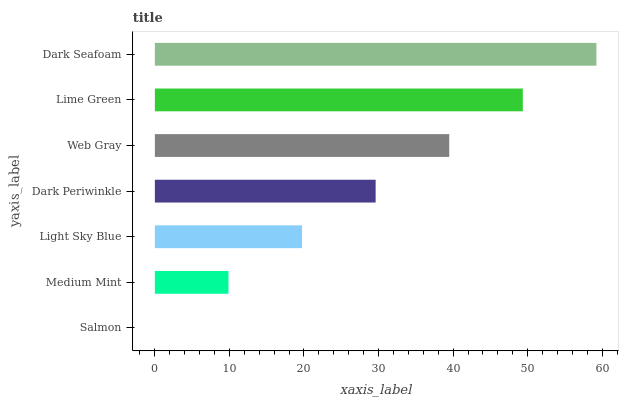Is Salmon the minimum?
Answer yes or no. Yes. Is Dark Seafoam the maximum?
Answer yes or no. Yes. Is Medium Mint the minimum?
Answer yes or no. No. Is Medium Mint the maximum?
Answer yes or no. No. Is Medium Mint greater than Salmon?
Answer yes or no. Yes. Is Salmon less than Medium Mint?
Answer yes or no. Yes. Is Salmon greater than Medium Mint?
Answer yes or no. No. Is Medium Mint less than Salmon?
Answer yes or no. No. Is Dark Periwinkle the high median?
Answer yes or no. Yes. Is Dark Periwinkle the low median?
Answer yes or no. Yes. Is Lime Green the high median?
Answer yes or no. No. Is Web Gray the low median?
Answer yes or no. No. 